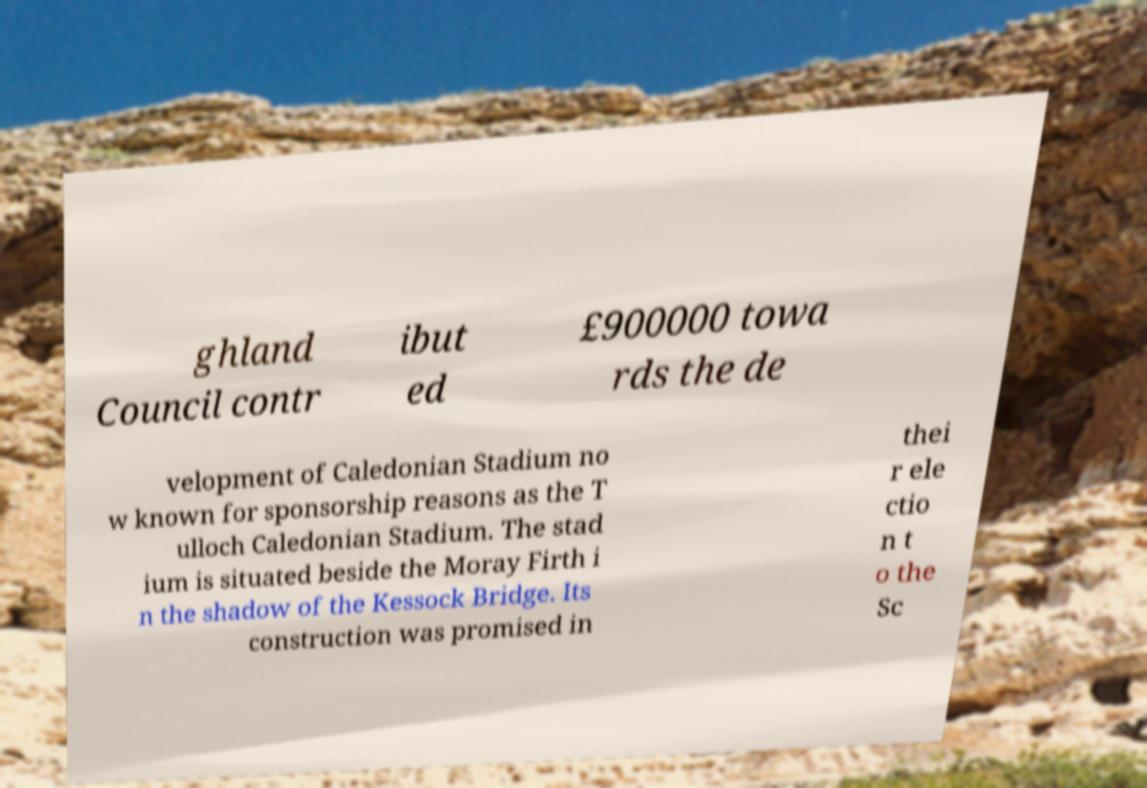For documentation purposes, I need the text within this image transcribed. Could you provide that? ghland Council contr ibut ed £900000 towa rds the de velopment of Caledonian Stadium no w known for sponsorship reasons as the T ulloch Caledonian Stadium. The stad ium is situated beside the Moray Firth i n the shadow of the Kessock Bridge. Its construction was promised in thei r ele ctio n t o the Sc 